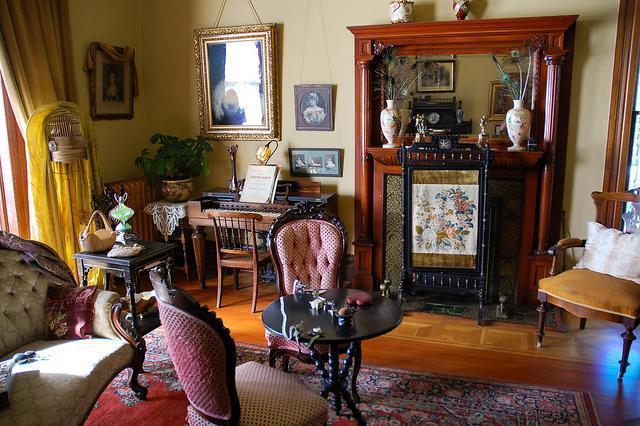How many chairs are there?
Give a very brief answer. 4. How many chairs are in the photo?
Give a very brief answer. 4. 